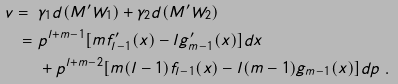Convert formula to latex. <formula><loc_0><loc_0><loc_500><loc_500>v = \ & \gamma _ { 1 } d ( M ^ { \prime } W _ { 1 } ) + \gamma _ { 2 } d ( M ^ { \prime } W _ { 2 } ) \\ = \ & p ^ { l + m - 1 } [ m f ^ { \prime } _ { l - 1 } ( x ) - l g ^ { \prime } _ { m - 1 } ( x ) ] d x \\ & + p ^ { l + m - 2 } [ m ( l - 1 ) f _ { l - 1 } ( x ) - l ( m - 1 ) g _ { m - 1 } ( x ) ] d p \ .</formula> 